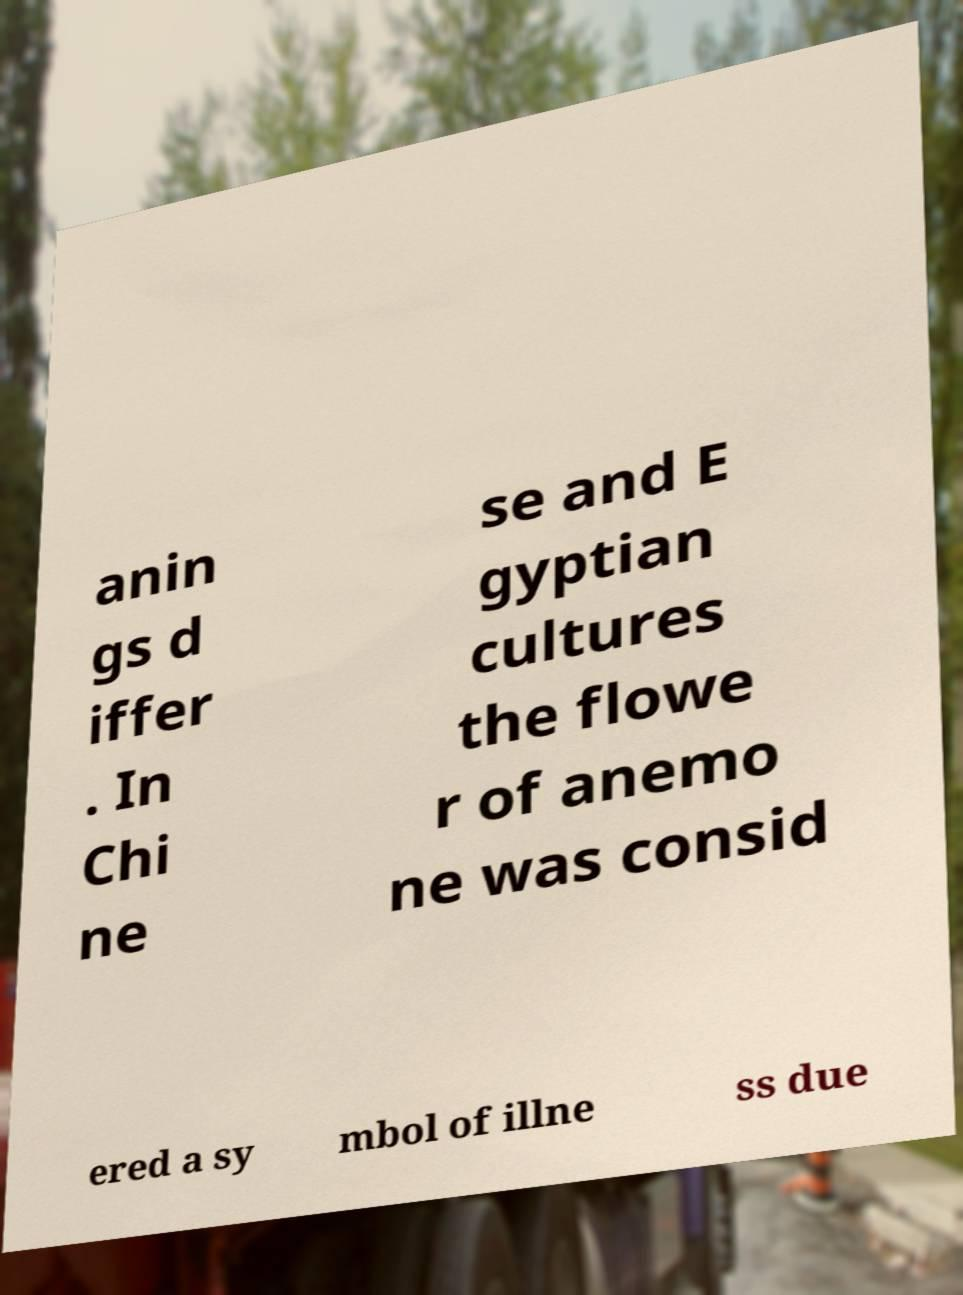What messages or text are displayed in this image? I need them in a readable, typed format. anin gs d iffer . In Chi ne se and E gyptian cultures the flowe r of anemo ne was consid ered a sy mbol of illne ss due 